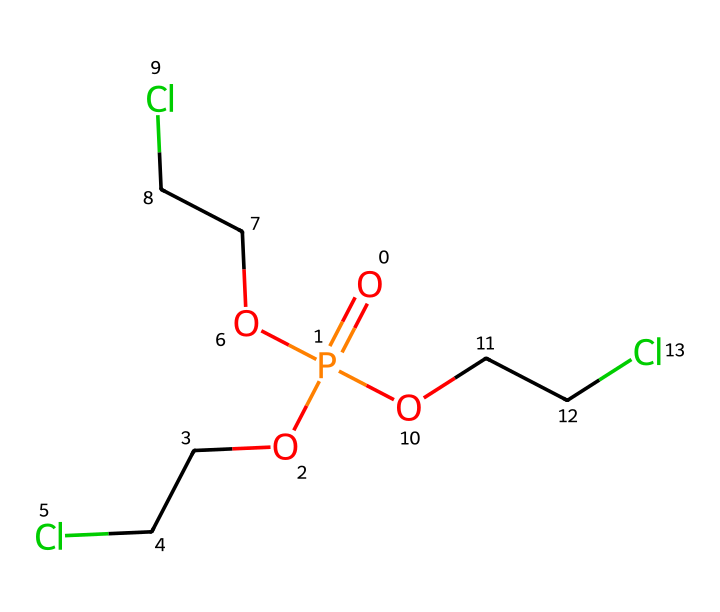What is the total number of carbon atoms in this chemical? By examining the SMILES representation, we can identify that each "C" in the structure denotes a carbon atom. The given SMILES shows three "C" within the branches attached to the phosphorus atom, and since there are three identical branches, the total number of carbon atoms is 9.
Answer: 9 How many chlorine atoms are present in this chemical? The SMILES representation includes "Cl" accompanying each of the three ethyl groups ("OCCCl"). Thus, there are three chlorine atoms, one in each of the three branches.
Answer: 3 What is the functional group of this chemical? The SMILES representation contains a phosphorus atom bonded to oxygen and carbon atoms, suggesting the presence of phosphate functional groups. The "O=P" indicates a phosphate group is present.
Answer: phosphate Is this compound likely to be highly soluble in water? Due to the presence of hydrophilic functional groups (alcohol and phosphate) from the "OCC" and "O=P" parts of the molecule, it suggests that this compound may interact favorably with water, leading to increased solubility.
Answer: yes What type of chemical is represented by this SMILES? Analyzing the structure reveals that it has a linear arrangement of carbon atoms and functional groups, which defines it as an aliphatic compound due to the presence of straight or branched carbon chains and no aromatic rings.
Answer: aliphatic What can be inferred about the flame retardant properties from the molecular structure? The presence of phosphorus and chlorine atoms in the structure typically indicates flame retardant properties, as these elements can form char and hinder combustion reactions.
Answer: flame retardant What is the role of chlorine in this compound? The chlorine atoms in the compound contribute to its flame retardant characteristics by releasing chlorine radicals during combustion, which disrupt flame propagation and help in reducing fire hazards.
Answer: flame retardant properties 